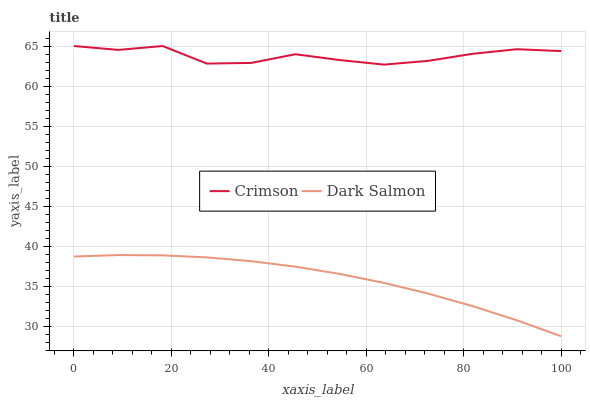Does Dark Salmon have the minimum area under the curve?
Answer yes or no. Yes. Does Crimson have the maximum area under the curve?
Answer yes or no. Yes. Does Dark Salmon have the maximum area under the curve?
Answer yes or no. No. Is Dark Salmon the smoothest?
Answer yes or no. Yes. Is Crimson the roughest?
Answer yes or no. Yes. Is Dark Salmon the roughest?
Answer yes or no. No. Does Dark Salmon have the highest value?
Answer yes or no. No. Is Dark Salmon less than Crimson?
Answer yes or no. Yes. Is Crimson greater than Dark Salmon?
Answer yes or no. Yes. Does Dark Salmon intersect Crimson?
Answer yes or no. No. 